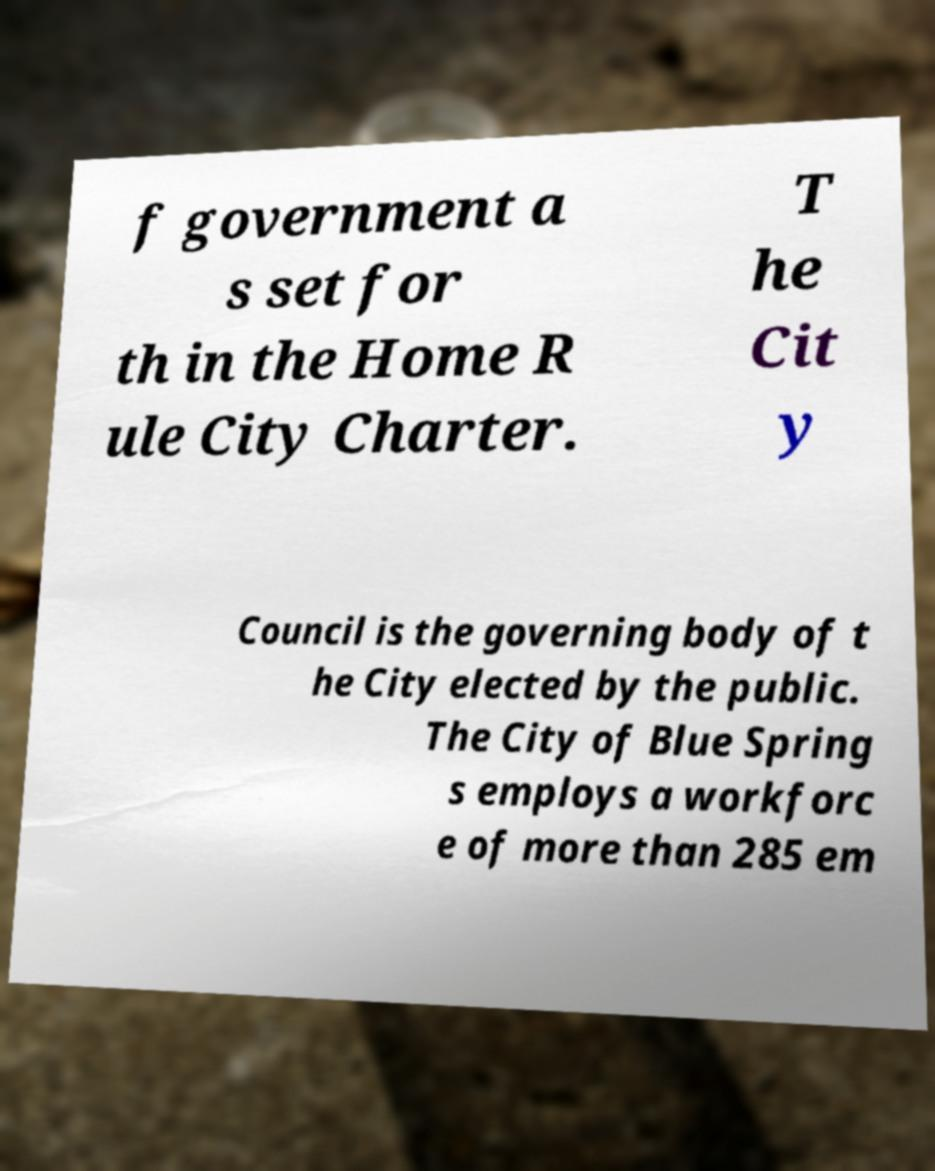Can you read and provide the text displayed in the image?This photo seems to have some interesting text. Can you extract and type it out for me? f government a s set for th in the Home R ule City Charter. T he Cit y Council is the governing body of t he City elected by the public. The City of Blue Spring s employs a workforc e of more than 285 em 